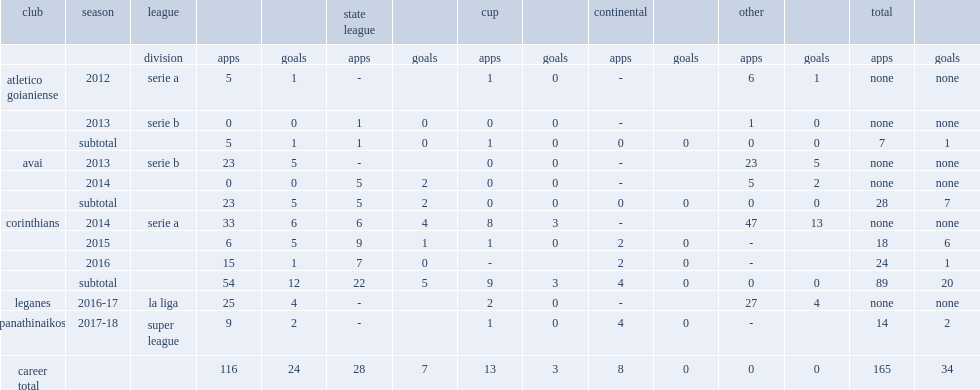Which league in 2013 did luciano move to avai? Serie b. 